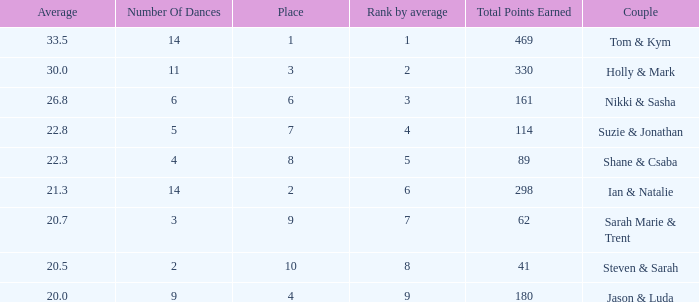What is the name of the couple if the total points earned is 161? Nikki & Sasha. 